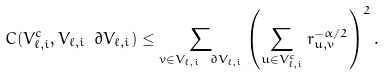<formula> <loc_0><loc_0><loc_500><loc_500>C ( V _ { \ell , i } ^ { c } , V _ { \ell , i } \ \partial V _ { \ell , i } ) \leq \sum _ { v \in V _ { \ell , i } \ \partial V _ { \ell , i } } \left ( \sum _ { u \in V _ { \ell , i } ^ { c } } r _ { u , v } ^ { - \alpha / 2 } \right ) ^ { 2 } .</formula> 